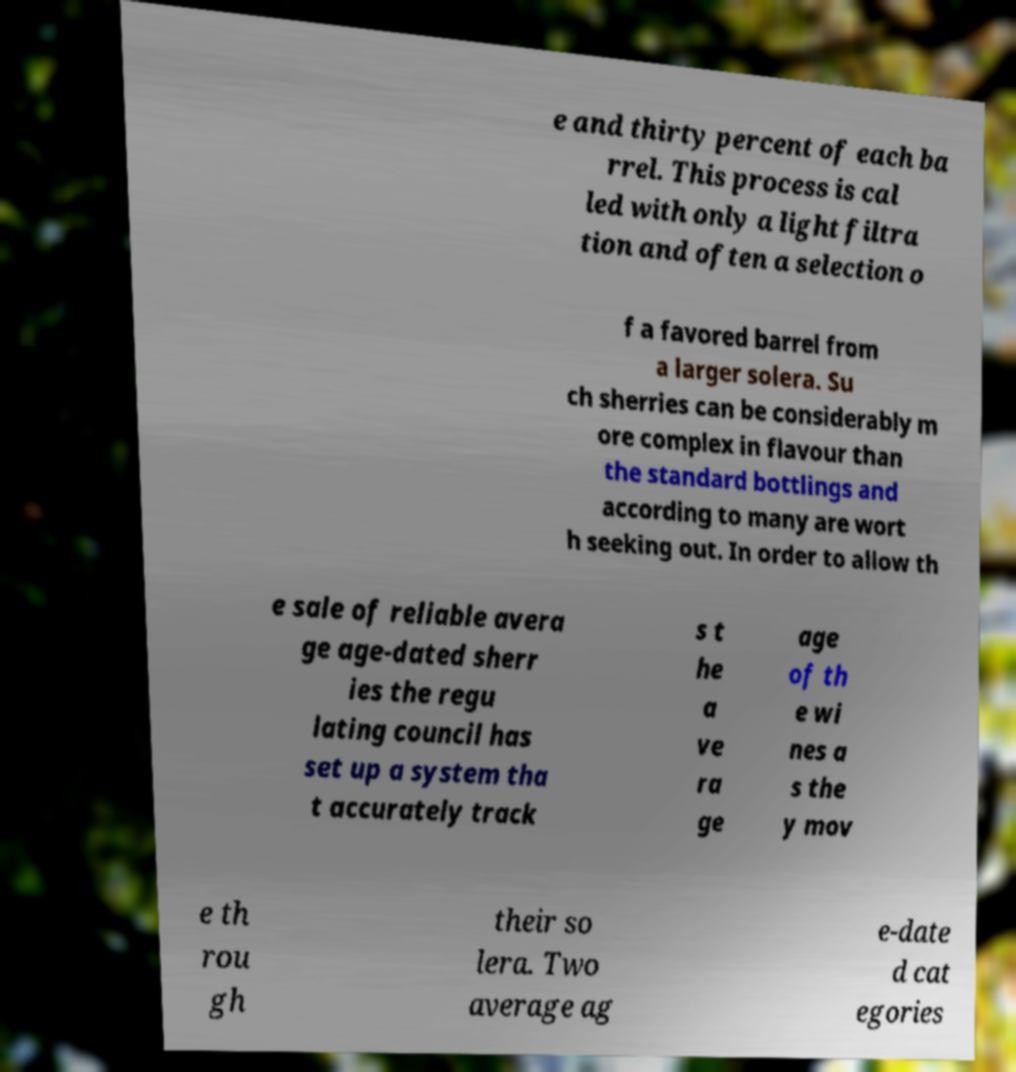I need the written content from this picture converted into text. Can you do that? e and thirty percent of each ba rrel. This process is cal led with only a light filtra tion and often a selection o f a favored barrel from a larger solera. Su ch sherries can be considerably m ore complex in flavour than the standard bottlings and according to many are wort h seeking out. In order to allow th e sale of reliable avera ge age-dated sherr ies the regu lating council has set up a system tha t accurately track s t he a ve ra ge age of th e wi nes a s the y mov e th rou gh their so lera. Two average ag e-date d cat egories 